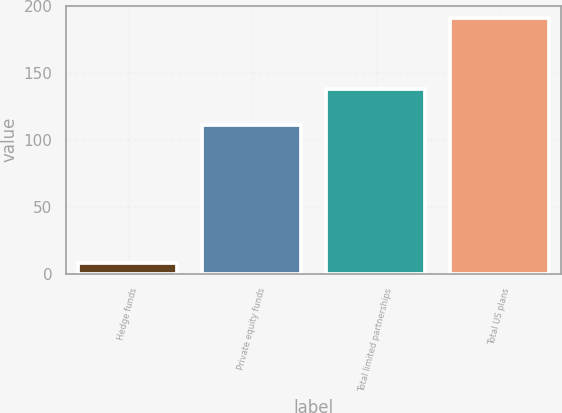<chart> <loc_0><loc_0><loc_500><loc_500><bar_chart><fcel>Hedge funds<fcel>Private equity funds<fcel>Total limited partnerships<fcel>Total US plans<nl><fcel>8<fcel>111<fcel>138<fcel>191<nl></chart> 